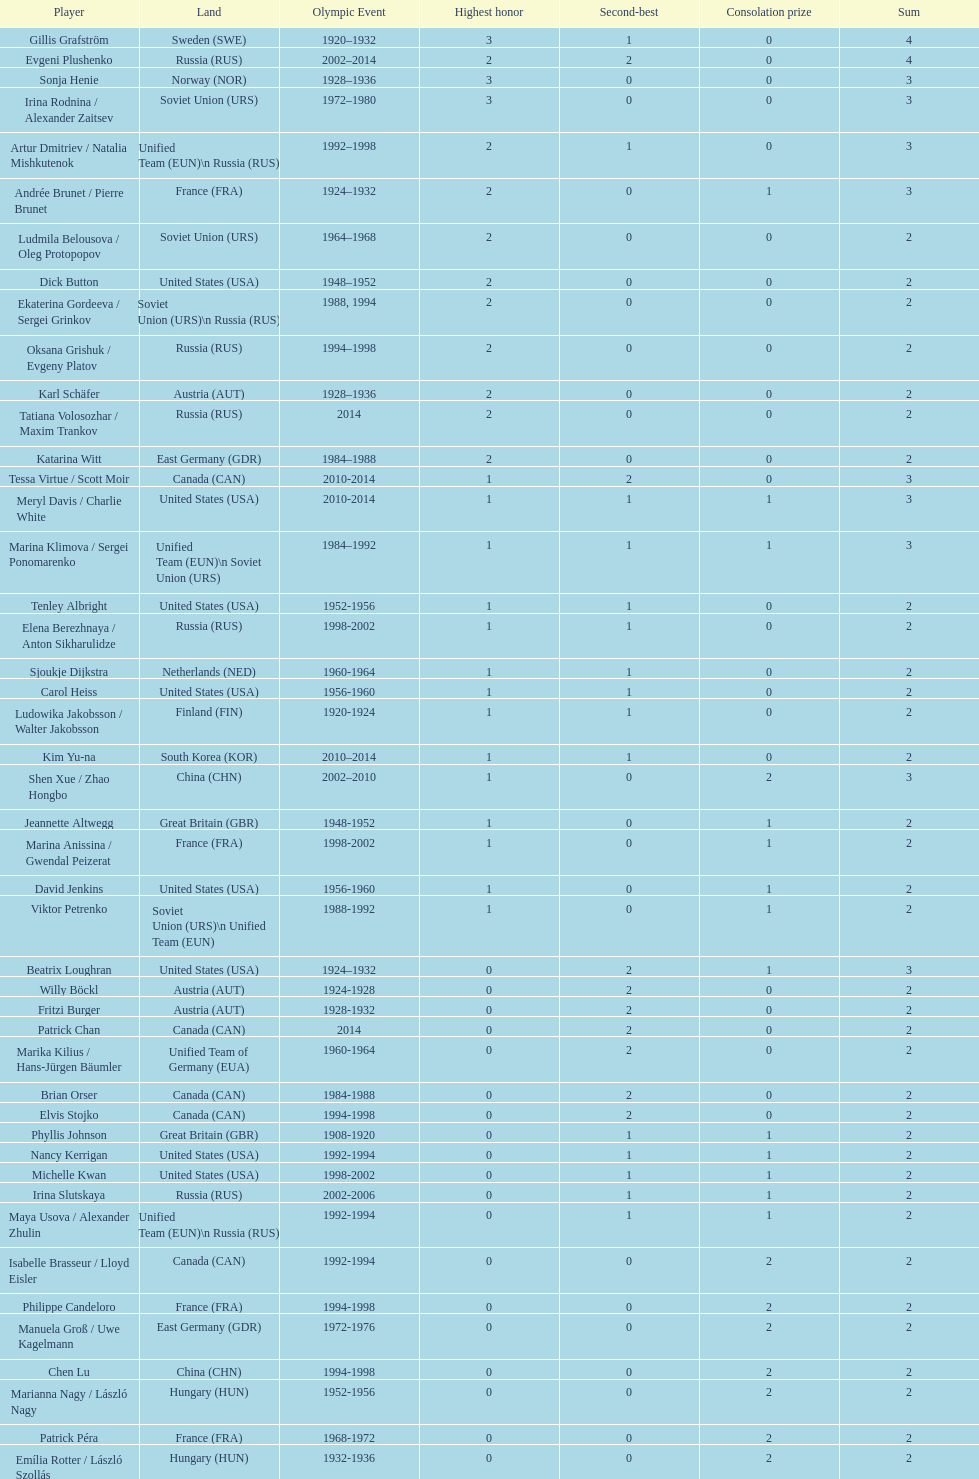Which nation was the first to win three gold medals for olympic figure skating? Sweden. 